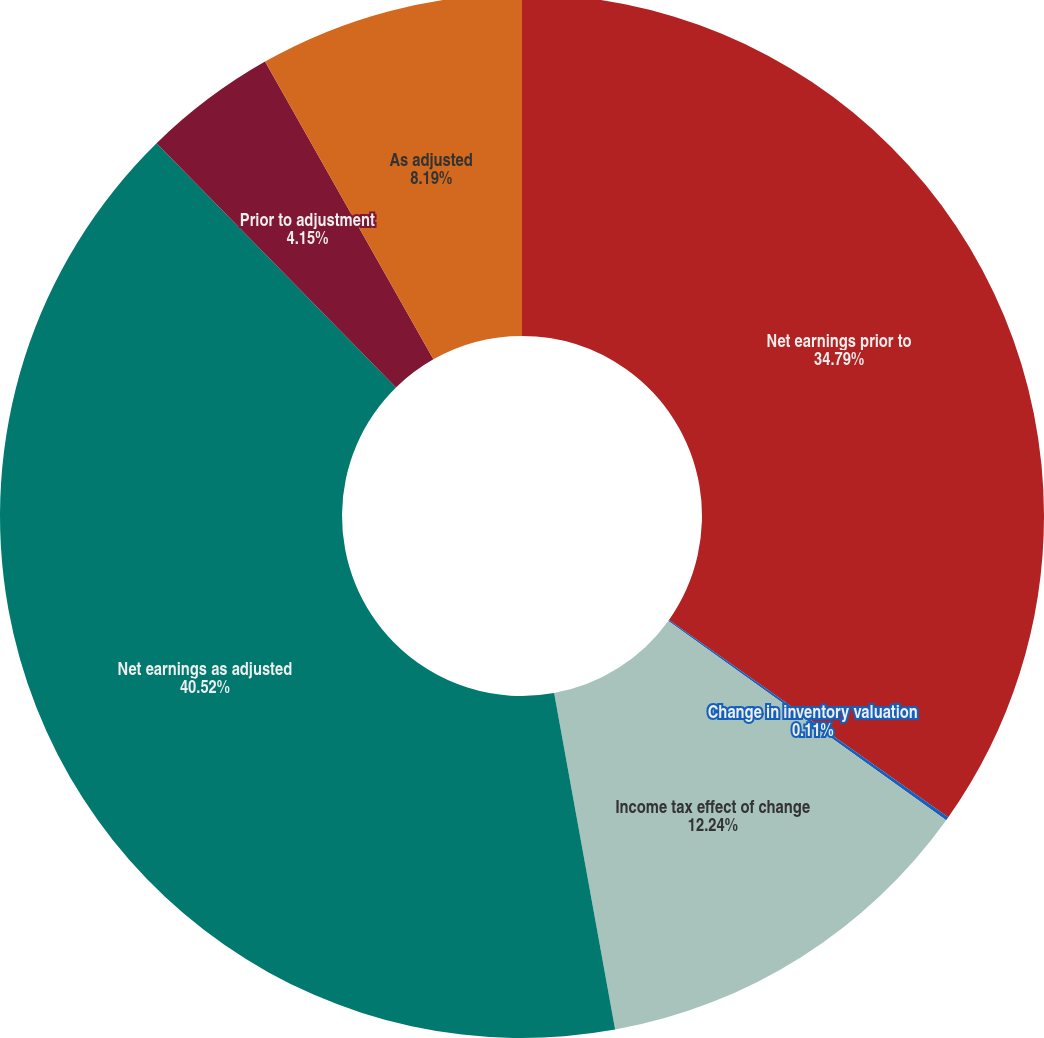Convert chart. <chart><loc_0><loc_0><loc_500><loc_500><pie_chart><fcel>Net earnings prior to<fcel>Change in inventory valuation<fcel>Income tax effect of change<fcel>Net earnings as adjusted<fcel>Prior to adjustment<fcel>As adjusted<nl><fcel>34.79%<fcel>0.11%<fcel>12.24%<fcel>40.51%<fcel>4.15%<fcel>8.19%<nl></chart> 